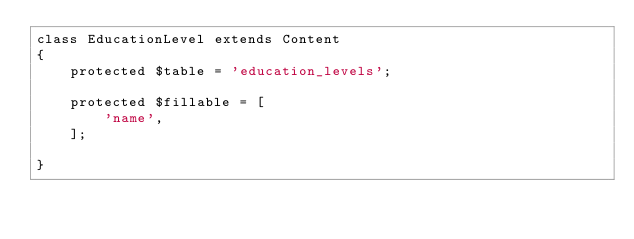Convert code to text. <code><loc_0><loc_0><loc_500><loc_500><_PHP_>class EducationLevel extends Content
{
    protected $table = 'education_levels';

    protected $fillable = [
        'name',
    ];

}
</code> 